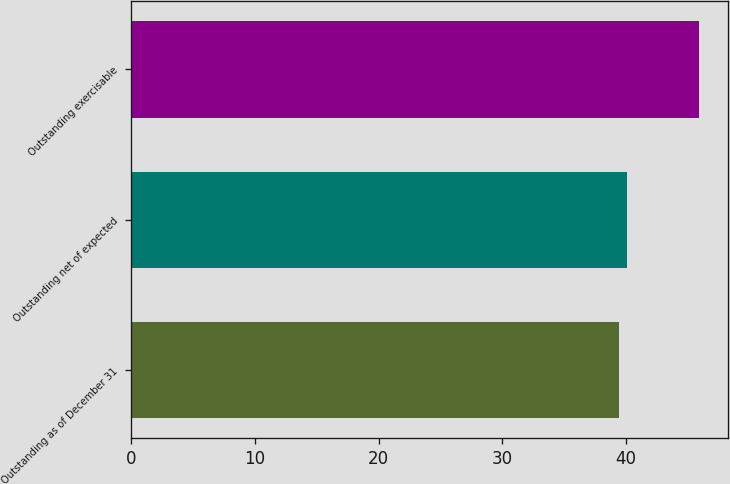Convert chart. <chart><loc_0><loc_0><loc_500><loc_500><bar_chart><fcel>Outstanding as of December 31<fcel>Outstanding net of expected<fcel>Outstanding exercisable<nl><fcel>39.39<fcel>40.04<fcel>45.92<nl></chart> 